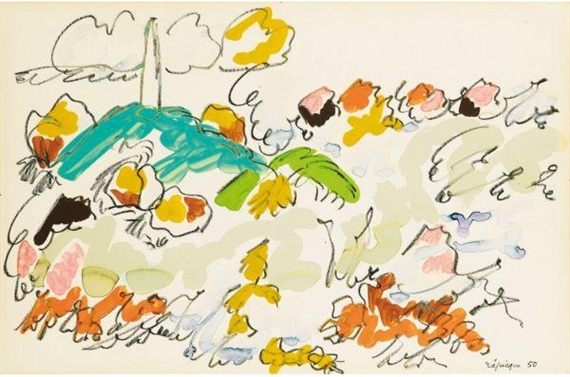What are the key elements in this picture? The image is a vibrant example of abstract expressionist art, emphasizing fluid forms and dynamic colors. Key elements include a prominent blue shape resembling a bird, and a green form that suggests a palm tree. Interspersed throughout the composition are various flower-like shapes in oranges, yellows, pinks, and blues. The background is predominantly white with hints of gray clouds, contributing to an airy, open feel. The undefined object forms invite viewers to engage their imagination and interpret the scene in a personal, unique manner. 